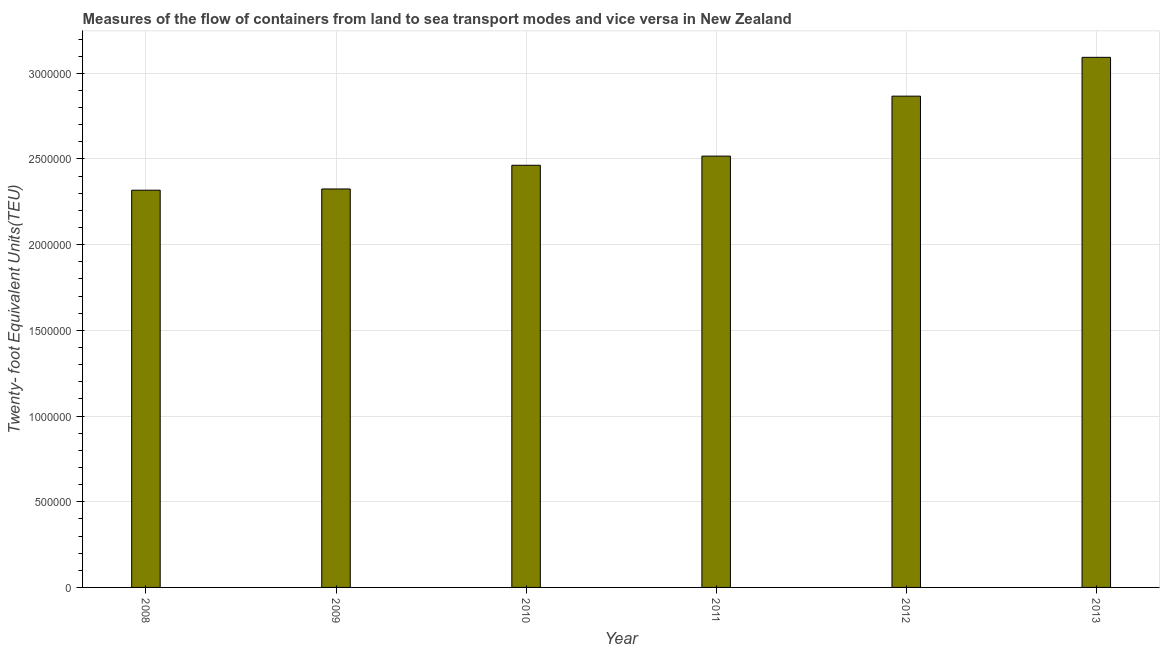Does the graph contain any zero values?
Your answer should be compact. No. What is the title of the graph?
Keep it short and to the point. Measures of the flow of containers from land to sea transport modes and vice versa in New Zealand. What is the label or title of the X-axis?
Keep it short and to the point. Year. What is the label or title of the Y-axis?
Your answer should be compact. Twenty- foot Equivalent Units(TEU). What is the container port traffic in 2008?
Give a very brief answer. 2.32e+06. Across all years, what is the maximum container port traffic?
Keep it short and to the point. 3.09e+06. Across all years, what is the minimum container port traffic?
Your response must be concise. 2.32e+06. In which year was the container port traffic maximum?
Provide a succinct answer. 2013. In which year was the container port traffic minimum?
Ensure brevity in your answer.  2008. What is the sum of the container port traffic?
Offer a terse response. 1.56e+07. What is the difference between the container port traffic in 2010 and 2012?
Provide a short and direct response. -4.03e+05. What is the average container port traffic per year?
Make the answer very short. 2.60e+06. What is the median container port traffic?
Make the answer very short. 2.49e+06. Do a majority of the years between 2009 and 2012 (inclusive) have container port traffic greater than 2100000 TEU?
Provide a short and direct response. Yes. What is the ratio of the container port traffic in 2010 to that in 2012?
Your answer should be very brief. 0.86. What is the difference between the highest and the second highest container port traffic?
Ensure brevity in your answer.  2.26e+05. Is the sum of the container port traffic in 2009 and 2013 greater than the maximum container port traffic across all years?
Your response must be concise. Yes. What is the difference between the highest and the lowest container port traffic?
Give a very brief answer. 7.75e+05. In how many years, is the container port traffic greater than the average container port traffic taken over all years?
Ensure brevity in your answer.  2. How many bars are there?
Your answer should be very brief. 6. How many years are there in the graph?
Give a very brief answer. 6. What is the Twenty- foot Equivalent Units(TEU) in 2008?
Your answer should be compact. 2.32e+06. What is the Twenty- foot Equivalent Units(TEU) in 2009?
Provide a short and direct response. 2.32e+06. What is the Twenty- foot Equivalent Units(TEU) in 2010?
Give a very brief answer. 2.46e+06. What is the Twenty- foot Equivalent Units(TEU) of 2011?
Your response must be concise. 2.52e+06. What is the Twenty- foot Equivalent Units(TEU) in 2012?
Your response must be concise. 2.87e+06. What is the Twenty- foot Equivalent Units(TEU) in 2013?
Ensure brevity in your answer.  3.09e+06. What is the difference between the Twenty- foot Equivalent Units(TEU) in 2008 and 2009?
Keep it short and to the point. -7146.69. What is the difference between the Twenty- foot Equivalent Units(TEU) in 2008 and 2010?
Provide a succinct answer. -1.45e+05. What is the difference between the Twenty- foot Equivalent Units(TEU) in 2008 and 2011?
Provide a succinct answer. -1.99e+05. What is the difference between the Twenty- foot Equivalent Units(TEU) in 2008 and 2012?
Your answer should be very brief. -5.49e+05. What is the difference between the Twenty- foot Equivalent Units(TEU) in 2008 and 2013?
Your answer should be compact. -7.75e+05. What is the difference between the Twenty- foot Equivalent Units(TEU) in 2009 and 2010?
Ensure brevity in your answer.  -1.38e+05. What is the difference between the Twenty- foot Equivalent Units(TEU) in 2009 and 2011?
Offer a terse response. -1.92e+05. What is the difference between the Twenty- foot Equivalent Units(TEU) in 2009 and 2012?
Provide a succinct answer. -5.42e+05. What is the difference between the Twenty- foot Equivalent Units(TEU) in 2009 and 2013?
Your answer should be very brief. -7.68e+05. What is the difference between the Twenty- foot Equivalent Units(TEU) in 2010 and 2011?
Offer a very short reply. -5.34e+04. What is the difference between the Twenty- foot Equivalent Units(TEU) in 2010 and 2012?
Your response must be concise. -4.03e+05. What is the difference between the Twenty- foot Equivalent Units(TEU) in 2010 and 2013?
Provide a succinct answer. -6.30e+05. What is the difference between the Twenty- foot Equivalent Units(TEU) in 2011 and 2012?
Keep it short and to the point. -3.50e+05. What is the difference between the Twenty- foot Equivalent Units(TEU) in 2011 and 2013?
Offer a terse response. -5.76e+05. What is the difference between the Twenty- foot Equivalent Units(TEU) in 2012 and 2013?
Provide a succinct answer. -2.26e+05. What is the ratio of the Twenty- foot Equivalent Units(TEU) in 2008 to that in 2009?
Your answer should be compact. 1. What is the ratio of the Twenty- foot Equivalent Units(TEU) in 2008 to that in 2010?
Make the answer very short. 0.94. What is the ratio of the Twenty- foot Equivalent Units(TEU) in 2008 to that in 2011?
Offer a terse response. 0.92. What is the ratio of the Twenty- foot Equivalent Units(TEU) in 2008 to that in 2012?
Offer a terse response. 0.81. What is the ratio of the Twenty- foot Equivalent Units(TEU) in 2008 to that in 2013?
Your answer should be compact. 0.75. What is the ratio of the Twenty- foot Equivalent Units(TEU) in 2009 to that in 2010?
Ensure brevity in your answer.  0.94. What is the ratio of the Twenty- foot Equivalent Units(TEU) in 2009 to that in 2011?
Your response must be concise. 0.92. What is the ratio of the Twenty- foot Equivalent Units(TEU) in 2009 to that in 2012?
Give a very brief answer. 0.81. What is the ratio of the Twenty- foot Equivalent Units(TEU) in 2009 to that in 2013?
Offer a very short reply. 0.75. What is the ratio of the Twenty- foot Equivalent Units(TEU) in 2010 to that in 2011?
Give a very brief answer. 0.98. What is the ratio of the Twenty- foot Equivalent Units(TEU) in 2010 to that in 2012?
Offer a terse response. 0.86. What is the ratio of the Twenty- foot Equivalent Units(TEU) in 2010 to that in 2013?
Your answer should be very brief. 0.8. What is the ratio of the Twenty- foot Equivalent Units(TEU) in 2011 to that in 2012?
Offer a terse response. 0.88. What is the ratio of the Twenty- foot Equivalent Units(TEU) in 2011 to that in 2013?
Offer a very short reply. 0.81. What is the ratio of the Twenty- foot Equivalent Units(TEU) in 2012 to that in 2013?
Provide a succinct answer. 0.93. 